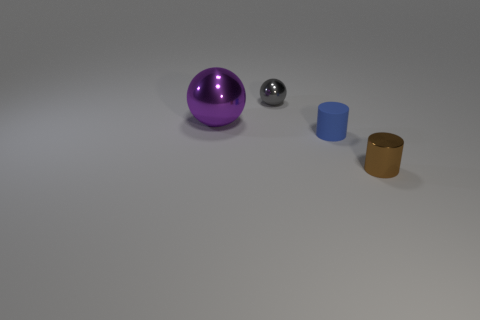Is there a large purple sphere made of the same material as the purple thing?
Your response must be concise. No. How many yellow objects are either rubber cylinders or big shiny cylinders?
Keep it short and to the point. 0. Are there any things that have the same color as the big metallic ball?
Provide a short and direct response. No. What size is the gray object that is made of the same material as the large purple sphere?
Make the answer very short. Small. What number of cubes are green metal objects or blue things?
Provide a succinct answer. 0. Are there more shiny objects than red rubber things?
Provide a short and direct response. Yes. How many green metal balls are the same size as the rubber cylinder?
Ensure brevity in your answer.  0. How many things are either shiny things behind the small brown metal thing or small metallic objects?
Offer a terse response. 3. Are there fewer big yellow matte blocks than large things?
Provide a succinct answer. Yes. What shape is the brown object that is the same material as the tiny gray object?
Make the answer very short. Cylinder. 